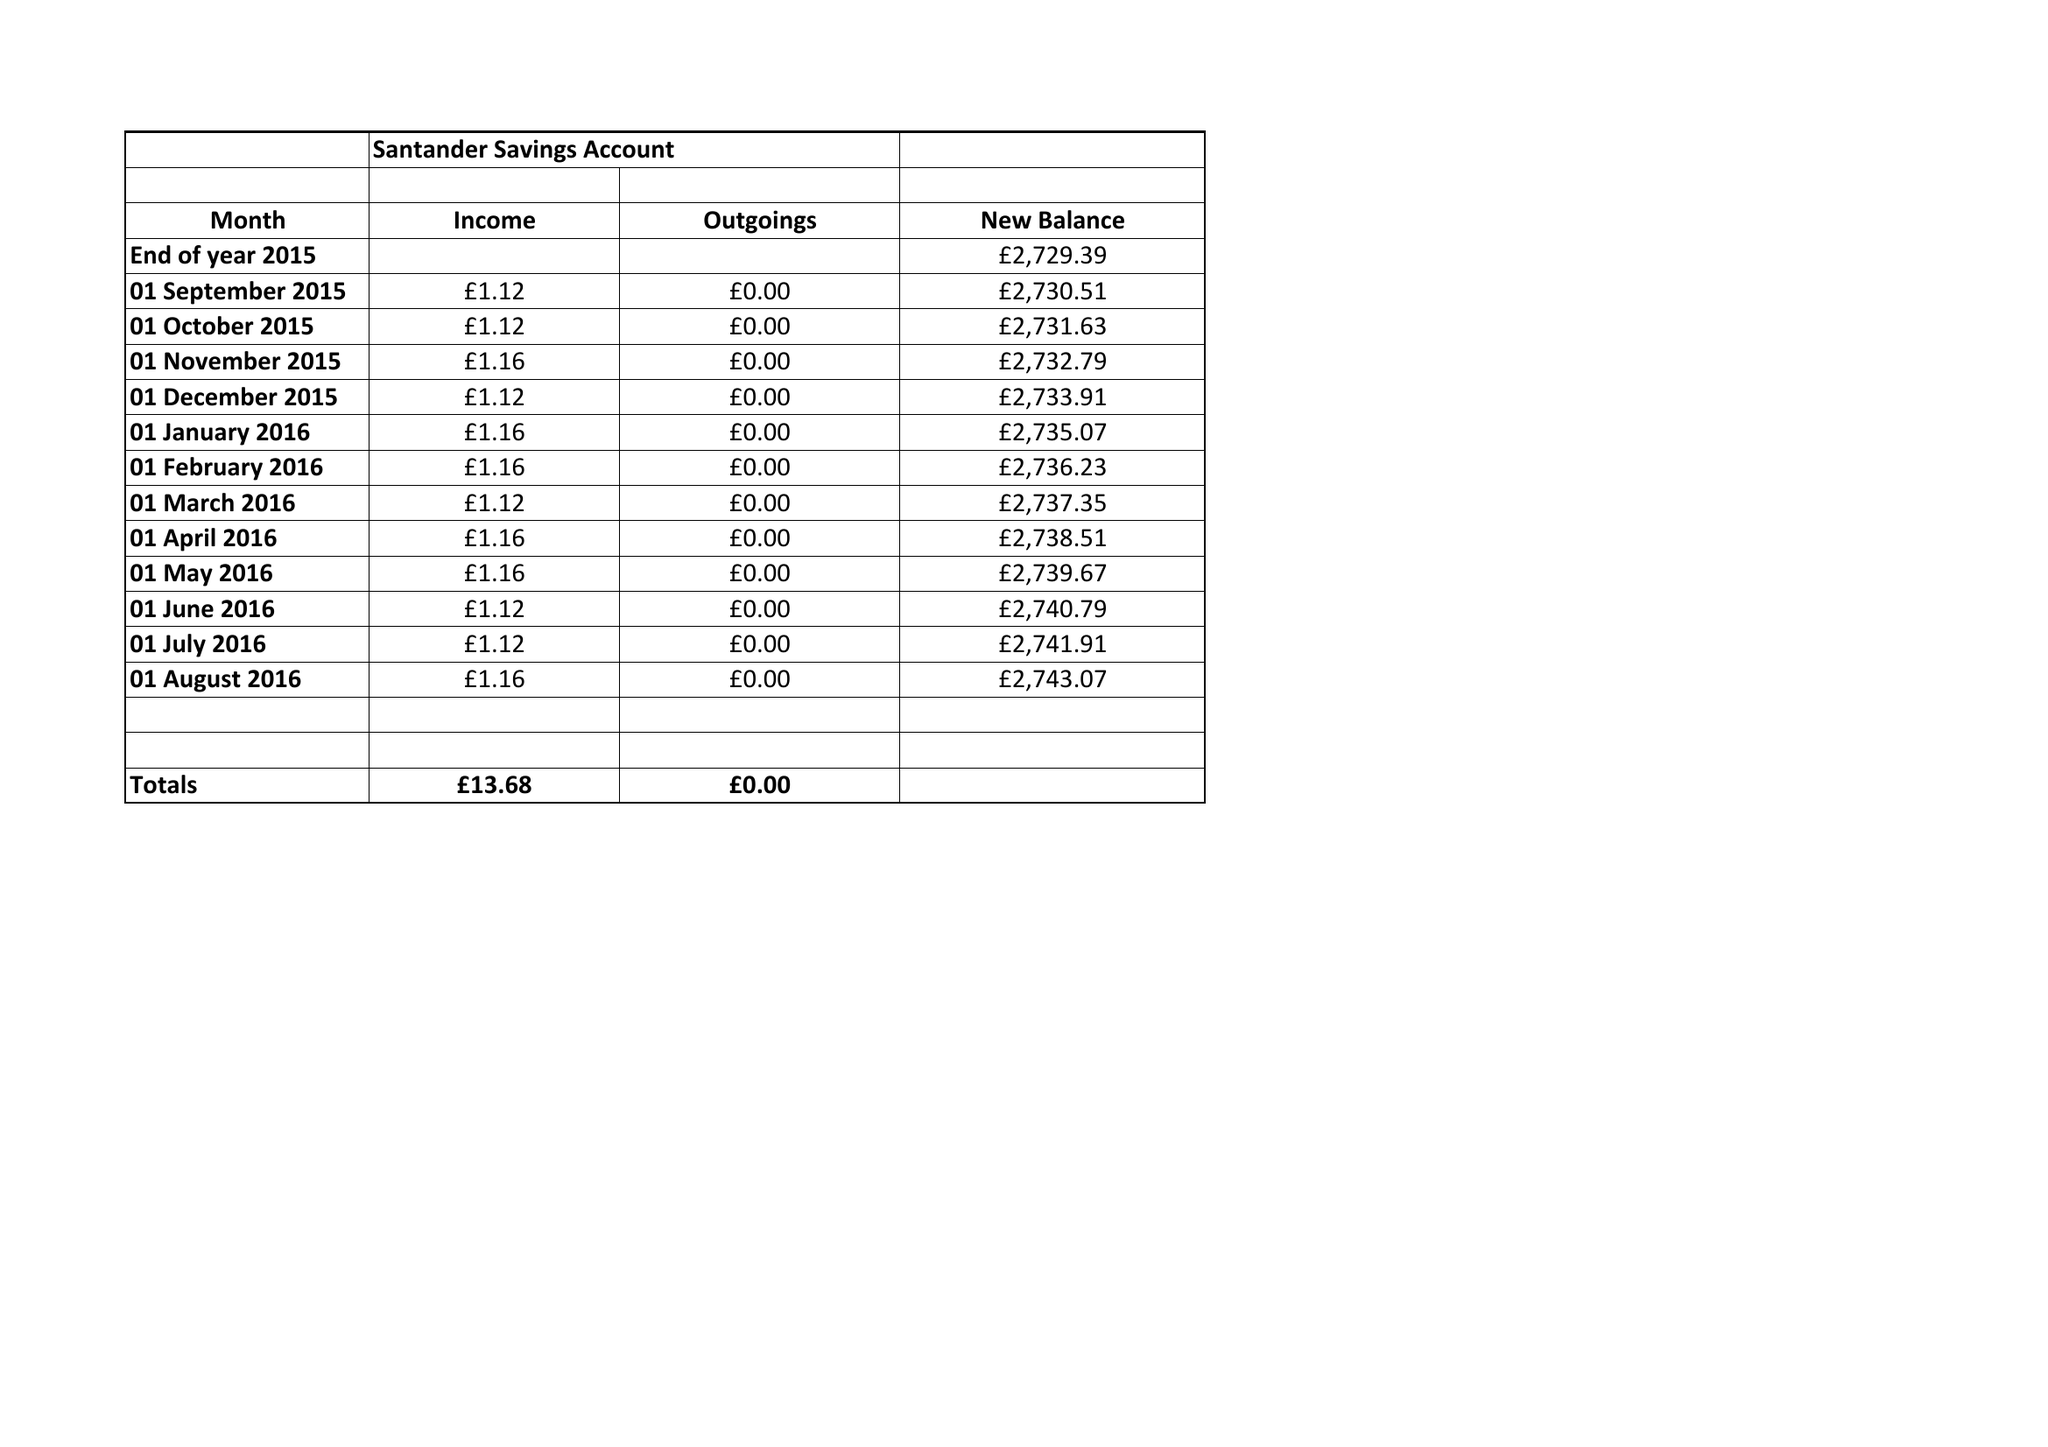What is the value for the income_annually_in_british_pounds?
Answer the question using a single word or phrase. 58943.98 